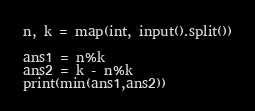<code> <loc_0><loc_0><loc_500><loc_500><_Python_>n, k = map(int, input().split())

ans1 = n%k
ans2 = k - n%k
print(min(ans1,ans2))
</code> 